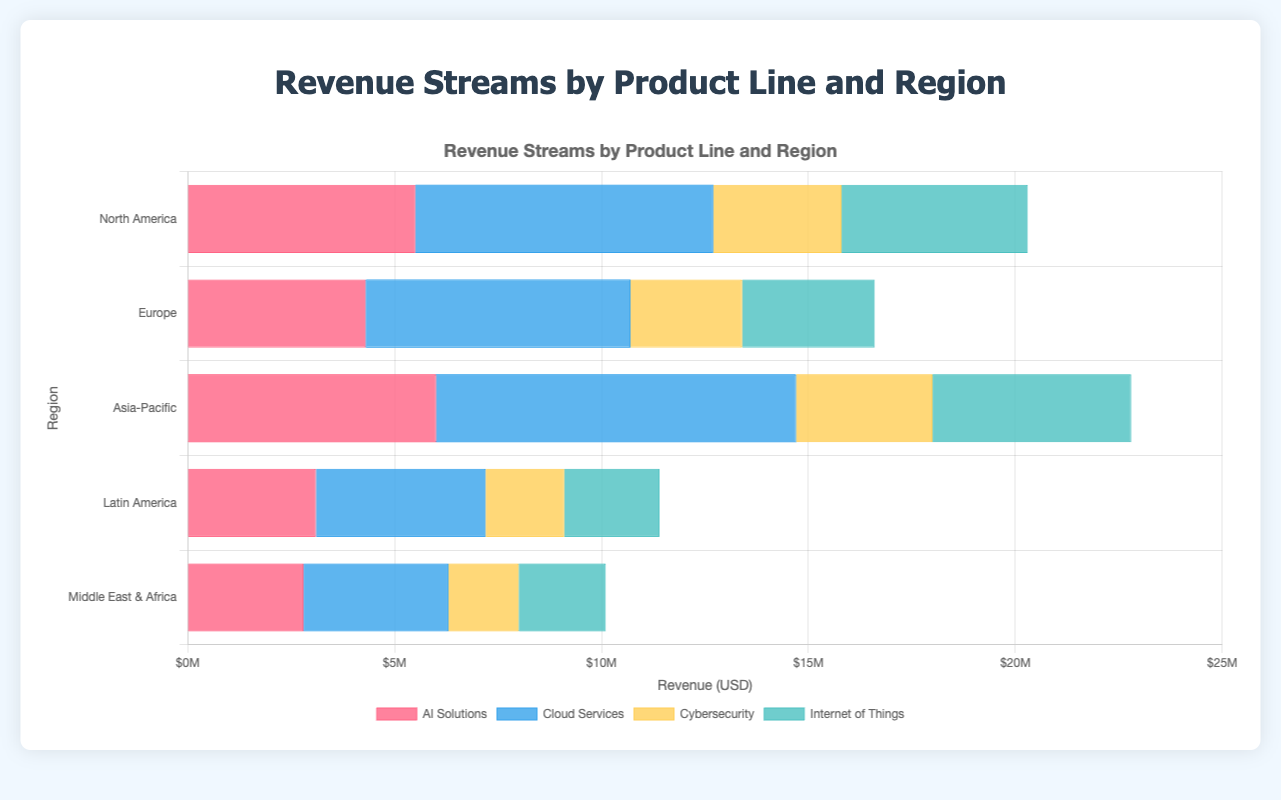What is the total revenue generated by AI Solutions and Cybersecurity in Asia-Pacific? First, we extract the revenue of AI Solutions and Cybersecurity in Asia-Pacific from the figure, which are $6,000,000 and $3,300,000 respectively. Then, we sum these two values: $6,000,000 + $3,300,000 = $9,300,000
Answer: $9,300,000 Which product line generates the most revenue in Europe? From the figure, we identify the revenue of each product line in Europe: AI Solutions ($4,300,000), Cloud Services ($6,400,000), Cybersecurity ($2,700,000), and Internet of Things ($3,200,000). The highest value is for Cloud Services.
Answer: Cloud Services What is the revenue difference between Cloud Services in North America and Middle East & Africa? First, we find the revenue values for Cloud Services in North America ($7,200,000) and Middle East & Africa ($3,500,000). Then, we calculate the difference: $7,200,000 - $3,500,000 = $3,700,000
Answer: $3,700,000 Which region has the lowest total revenue from all product lines combined? We calculate the total revenue for each region: North America ($20,100,000), Europe ($16,300,000), Asia-Pacific ($22,900,000), Latin America ($11,400,000), and Middle East & Africa ($10,300,000). The lowest total is for Middle East & Africa.
Answer: Middle East & Africa In which region is the least revenue generated for the Internet of Things? From the figure, the revenue for the Internet of Things in each region is: North America ($4,500,000), Europe ($3,200,000), Asia-Pacific ($4,800,000), Latin America ($2,300,000), and Middle East & Africa ($2,100,000). The lowest value is in Middle East & Africa.
Answer: Middle East & Africa Compare the revenue of AI Solutions between North America and Europe. Which one is higher, and by how much? The revenue for AI Solutions in North America is $5,500,000 and in Europe is $4,300,000. North America has higher revenue, and the difference is $5,500,000 - $4,300,000 = $1,200,000
Answer: North America, $1,200,000 What is the average revenue generated by Cloud Services across all regions? We sum the revenue of Cloud Services for all regions: $7,200,000 (North America) + $6,400,000 (Europe) + $8,700,000 (Asia-Pacific) + $4,100,000 (Latin America) + $3,500,000 (Middle East & Africa) = $29,900,000. Then, we divide by the number of regions (5): $29,900,000 / 5 = $5,980,000
Answer: $5,980,000 Which region has the highest revenue for Cybersecurity, and what is that revenue? From the figure, the revenue for Cybersecurity is: North America ($3,100,000), Europe ($2,700,000), Asia-Pacific ($3,300,000), Latin America ($1,900,000), and Middle East & Africa ($1,700,000). The highest value is in Asia-Pacific.
Answer: Asia-Pacific, $3,300,000 What is the combined revenue of North America and Europe for all product lines? We first calculate the total revenue of all product lines in North America ($5,500,000 + $7,200,000 + $3,100,000 + $4,500,000 = $20,300,000) and in Europe ($4,300,000 + $6,400,000 + $2,700,000 + $3,200,000 = $16,600,000). Then, we sum these totals: $20,300,000 + $16,600,000 = $36,900,000
Answer: $36,900,000 